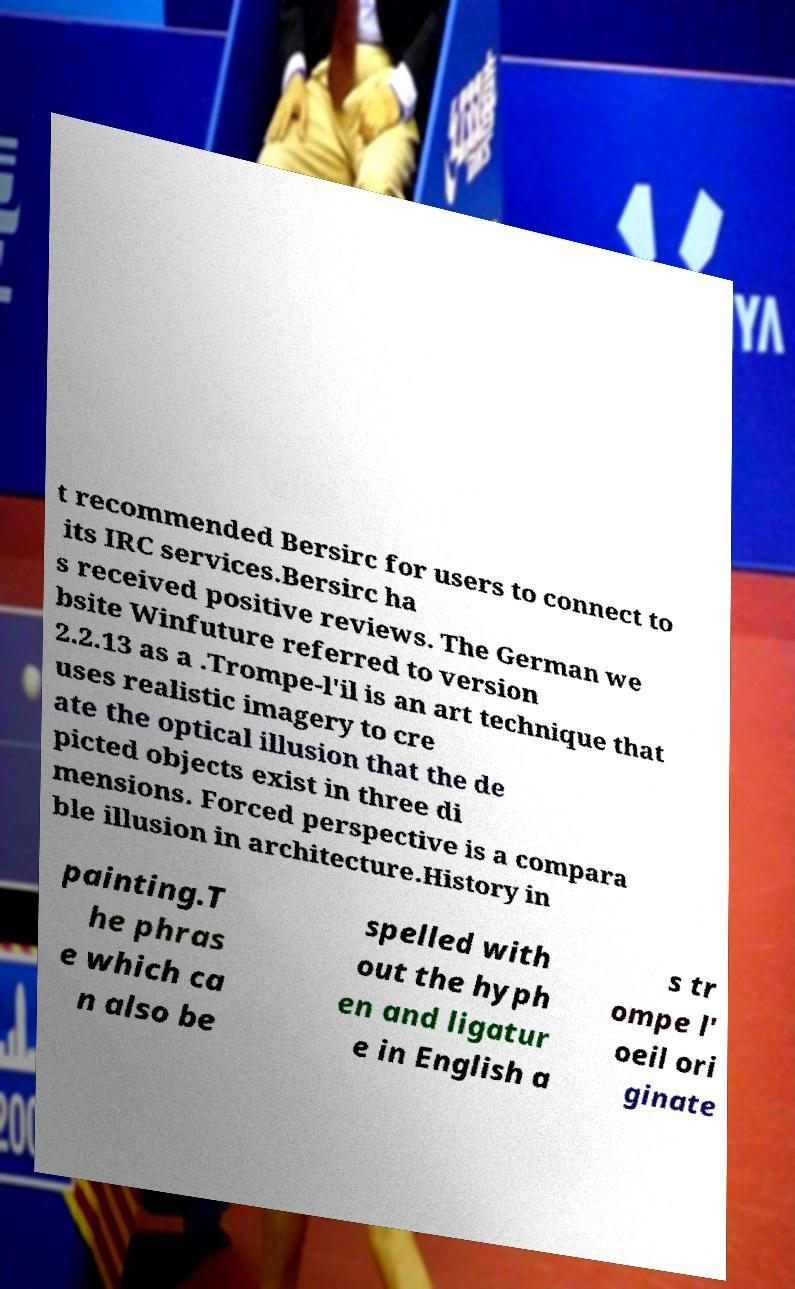There's text embedded in this image that I need extracted. Can you transcribe it verbatim? t recommended Bersirc for users to connect to its IRC services.Bersirc ha s received positive reviews. The German we bsite Winfuture referred to version 2.2.13 as a .Trompe-l'il is an art technique that uses realistic imagery to cre ate the optical illusion that the de picted objects exist in three di mensions. Forced perspective is a compara ble illusion in architecture.History in painting.T he phras e which ca n also be spelled with out the hyph en and ligatur e in English a s tr ompe l' oeil ori ginate 